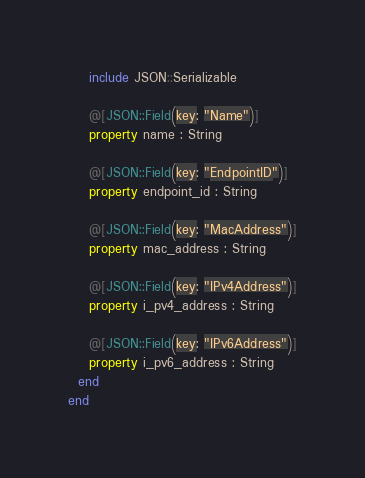<code> <loc_0><loc_0><loc_500><loc_500><_Crystal_>    include JSON::Serializable

    @[JSON::Field(key: "Name")]
    property name : String

    @[JSON::Field(key: "EndpointID")]
    property endpoint_id : String

    @[JSON::Field(key: "MacAddress")]
    property mac_address : String

    @[JSON::Field(key: "IPv4Address")]
    property i_pv4_address : String

    @[JSON::Field(key: "IPv6Address")]
    property i_pv6_address : String
  end
end
</code> 